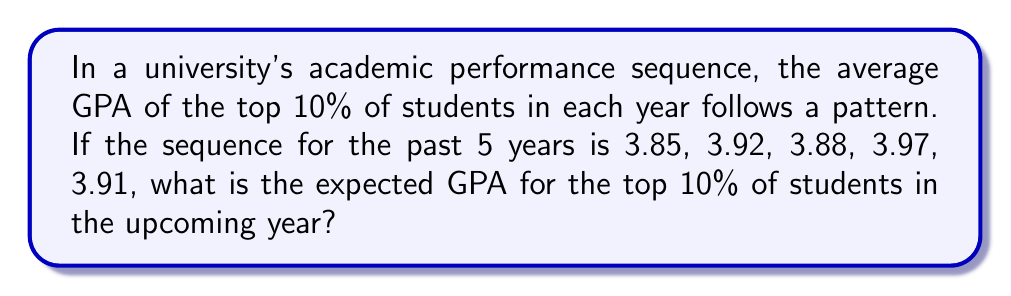Give your solution to this math problem. Let's approach this step-by-step:

1) First, we need to identify the pattern in the sequence:
   3.85, 3.92, 3.88, 3.97, 3.91

2) We can observe that the sequence alternates between increasing and decreasing:
   3.85 → 3.92 (increase)
   3.92 → 3.88 (decrease)
   3.88 → 3.97 (increase)
   3.97 → 3.91 (decrease)

3) The pattern of increase and decrease is consistent, but the magnitude varies.

4) Let's calculate the differences:
   3.92 - 3.85 = 0.07 (first increase)
   3.92 - 3.88 = 0.04 (first decrease)
   3.97 - 3.88 = 0.09 (second increase)
   3.97 - 3.91 = 0.06 (second decrease)

5) We can see that each subsequent change is larger:
   Increases: 0.07 → 0.09
   Decreases: 0.04 → 0.06

6) If this pattern continues, the next increase should be larger than 0.09.
   Let's assume it increases by 0.02 each time:
   0.07 → 0.09 → 0.11

7) Therefore, we expect the next term to increase by 0.11 from 3.91.

8) Calculate: 3.91 + 0.11 = 4.02

However, since GPAs are typically capped at 4.00, we should adjust our answer to 4.00.
Answer: 4.00 